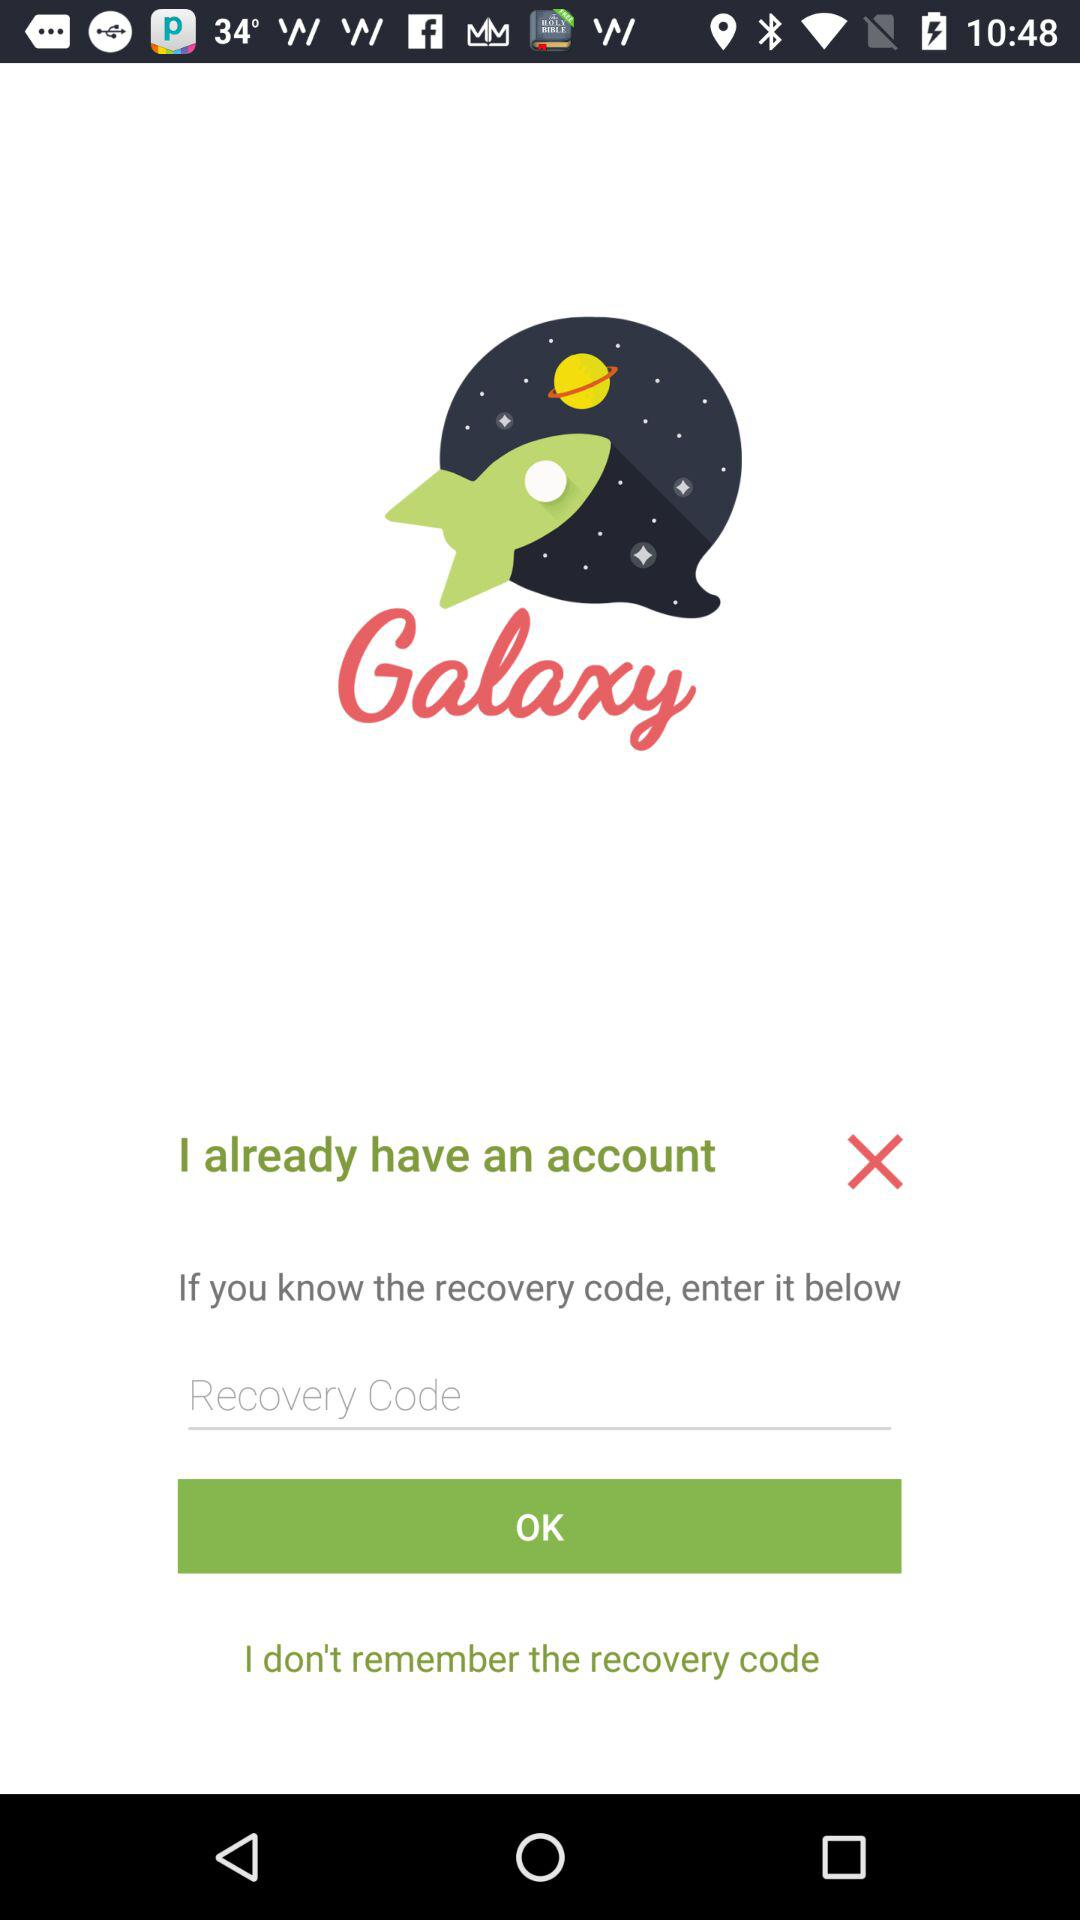What is the name of the application? The name of the application is "Galaxy". 